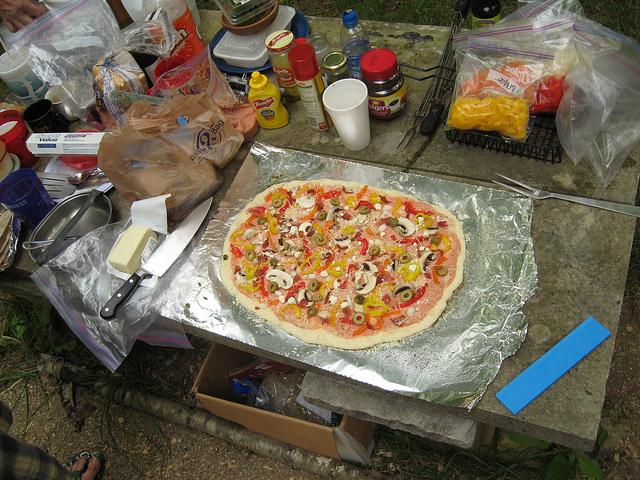What are the white blobs on the pizza?
Concise answer only. Mushrooms. Is this a large pizza?
Keep it brief. Yes. What is the brand of mustard?
Write a very short answer. French's. What are the yellow cans?
Short answer required. Mustard. Is this pizza ready?
Keep it brief. No. What kind of food is shown?
Answer briefly. Pizza. What vegetable is in this scene?
Give a very brief answer. Olives. What is covering the plate of pizza?
Concise answer only. Foil. 